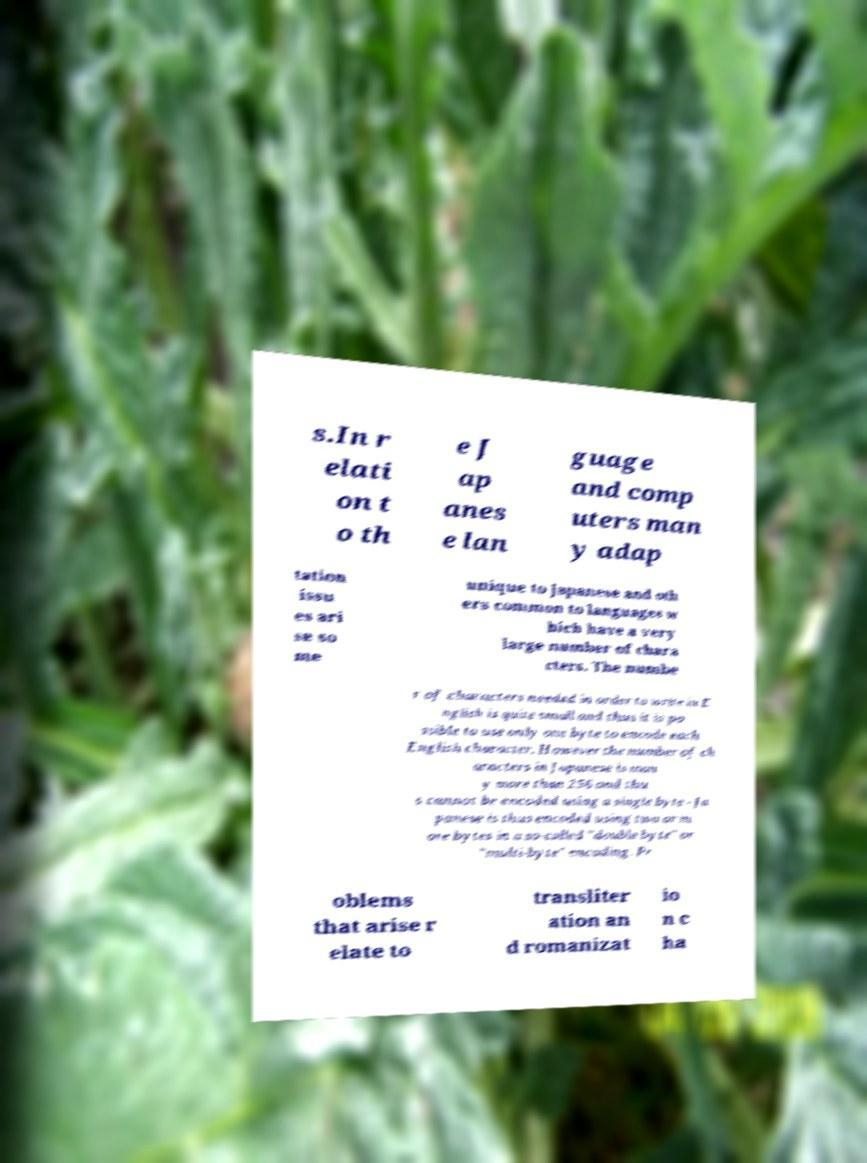Please identify and transcribe the text found in this image. s.In r elati on t o th e J ap anes e lan guage and comp uters man y adap tation issu es ari se so me unique to Japanese and oth ers common to languages w hich have a very large number of chara cters. The numbe r of characters needed in order to write in E nglish is quite small and thus it is po ssible to use only one byte to encode each English character. However the number of ch aracters in Japanese is man y more than 256 and thu s cannot be encoded using a single byte - Ja panese is thus encoded using two or m ore bytes in a so-called "double byte" or "multi-byte" encoding. Pr oblems that arise r elate to transliter ation an d romanizat io n c ha 